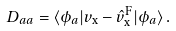<formula> <loc_0><loc_0><loc_500><loc_500>D _ { a a } = \langle \phi _ { a } | v _ { \text {x} } - \hat { v } _ { \text {x} } ^ { \text {F} } | \phi _ { a } \rangle \, .</formula> 